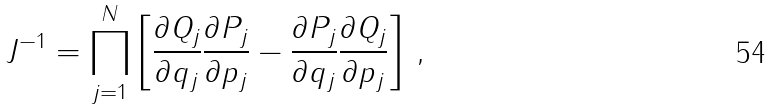Convert formula to latex. <formula><loc_0><loc_0><loc_500><loc_500>J ^ { - 1 } = \prod _ { j = 1 } ^ { N } \left [ \frac { \partial Q _ { j } } { \partial q _ { j } } \frac { \partial P _ { j } } { \partial p _ { j } } - \frac { \partial P _ { j } } { \partial q _ { j } } \frac { \partial Q _ { j } } { \partial p _ { j } } \right ] \, ,</formula> 